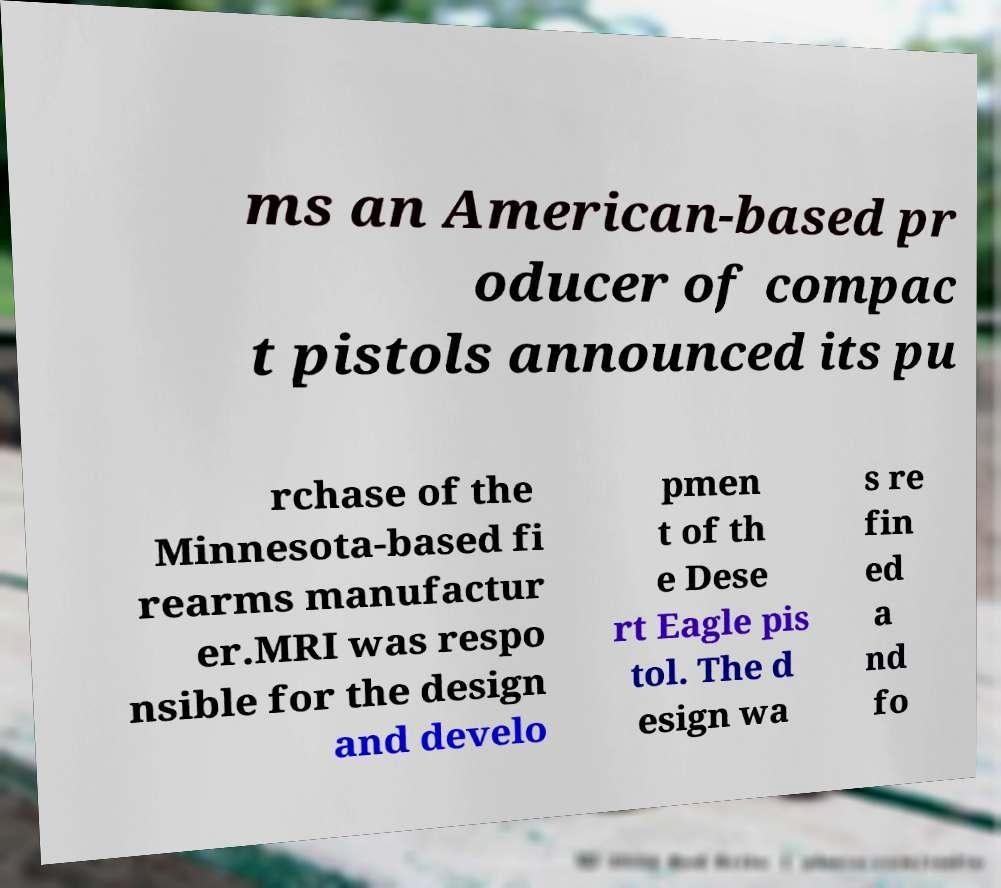Can you accurately transcribe the text from the provided image for me? ms an American-based pr oducer of compac t pistols announced its pu rchase of the Minnesota-based fi rearms manufactur er.MRI was respo nsible for the design and develo pmen t of th e Dese rt Eagle pis tol. The d esign wa s re fin ed a nd fo 